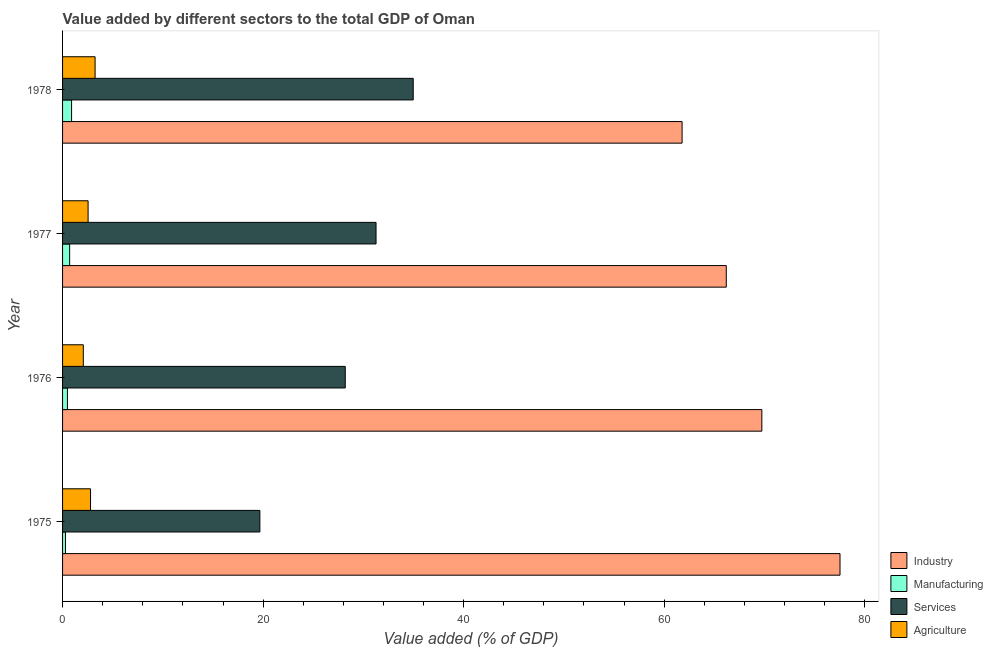How many different coloured bars are there?
Your answer should be very brief. 4. How many groups of bars are there?
Your answer should be compact. 4. Are the number of bars per tick equal to the number of legend labels?
Keep it short and to the point. Yes. Are the number of bars on each tick of the Y-axis equal?
Keep it short and to the point. Yes. How many bars are there on the 4th tick from the bottom?
Provide a succinct answer. 4. What is the label of the 1st group of bars from the top?
Your answer should be compact. 1978. What is the value added by manufacturing sector in 1976?
Offer a terse response. 0.49. Across all years, what is the maximum value added by industrial sector?
Your response must be concise. 77.53. Across all years, what is the minimum value added by services sector?
Your answer should be very brief. 19.68. In which year was the value added by manufacturing sector maximum?
Your response must be concise. 1978. In which year was the value added by manufacturing sector minimum?
Offer a terse response. 1975. What is the total value added by manufacturing sector in the graph?
Your response must be concise. 2.38. What is the difference between the value added by agricultural sector in 1975 and that in 1978?
Offer a terse response. -0.45. What is the difference between the value added by industrial sector in 1977 and the value added by services sector in 1975?
Make the answer very short. 46.51. What is the average value added by manufacturing sector per year?
Your answer should be compact. 0.59. In the year 1978, what is the difference between the value added by agricultural sector and value added by manufacturing sector?
Your response must be concise. 2.35. In how many years, is the value added by manufacturing sector greater than 16 %?
Provide a short and direct response. 0. What is the ratio of the value added by industrial sector in 1975 to that in 1976?
Provide a short and direct response. 1.11. Is the value added by services sector in 1975 less than that in 1976?
Offer a very short reply. Yes. What is the difference between the highest and the second highest value added by manufacturing sector?
Your answer should be compact. 0.19. What is the difference between the highest and the lowest value added by services sector?
Your answer should be compact. 15.29. In how many years, is the value added by services sector greater than the average value added by services sector taken over all years?
Offer a terse response. 2. Is it the case that in every year, the sum of the value added by services sector and value added by manufacturing sector is greater than the sum of value added by industrial sector and value added by agricultural sector?
Make the answer very short. Yes. What does the 4th bar from the top in 1978 represents?
Ensure brevity in your answer.  Industry. What does the 1st bar from the bottom in 1976 represents?
Offer a very short reply. Industry. Is it the case that in every year, the sum of the value added by industrial sector and value added by manufacturing sector is greater than the value added by services sector?
Make the answer very short. Yes. How many bars are there?
Provide a short and direct response. 16. Are all the bars in the graph horizontal?
Your answer should be compact. Yes. How many years are there in the graph?
Your answer should be very brief. 4. What is the difference between two consecutive major ticks on the X-axis?
Offer a very short reply. 20. Does the graph contain any zero values?
Your answer should be very brief. No. Does the graph contain grids?
Your answer should be compact. No. Where does the legend appear in the graph?
Ensure brevity in your answer.  Bottom right. How many legend labels are there?
Your answer should be very brief. 4. What is the title of the graph?
Provide a short and direct response. Value added by different sectors to the total GDP of Oman. What is the label or title of the X-axis?
Your answer should be very brief. Value added (% of GDP). What is the Value added (% of GDP) in Industry in 1975?
Offer a very short reply. 77.53. What is the Value added (% of GDP) of Manufacturing in 1975?
Your answer should be compact. 0.29. What is the Value added (% of GDP) of Services in 1975?
Keep it short and to the point. 19.68. What is the Value added (% of GDP) of Agriculture in 1975?
Offer a very short reply. 2.79. What is the Value added (% of GDP) of Industry in 1976?
Keep it short and to the point. 69.74. What is the Value added (% of GDP) in Manufacturing in 1976?
Your answer should be compact. 0.49. What is the Value added (% of GDP) of Services in 1976?
Provide a short and direct response. 28.19. What is the Value added (% of GDP) of Agriculture in 1976?
Provide a succinct answer. 2.07. What is the Value added (% of GDP) in Industry in 1977?
Provide a short and direct response. 66.19. What is the Value added (% of GDP) in Manufacturing in 1977?
Provide a short and direct response. 0.71. What is the Value added (% of GDP) in Services in 1977?
Make the answer very short. 31.26. What is the Value added (% of GDP) in Agriculture in 1977?
Give a very brief answer. 2.55. What is the Value added (% of GDP) of Industry in 1978?
Your answer should be very brief. 61.79. What is the Value added (% of GDP) in Manufacturing in 1978?
Your answer should be compact. 0.9. What is the Value added (% of GDP) of Services in 1978?
Keep it short and to the point. 34.97. What is the Value added (% of GDP) in Agriculture in 1978?
Make the answer very short. 3.24. Across all years, what is the maximum Value added (% of GDP) of Industry?
Keep it short and to the point. 77.53. Across all years, what is the maximum Value added (% of GDP) in Manufacturing?
Your answer should be compact. 0.9. Across all years, what is the maximum Value added (% of GDP) of Services?
Make the answer very short. 34.97. Across all years, what is the maximum Value added (% of GDP) of Agriculture?
Keep it short and to the point. 3.24. Across all years, what is the minimum Value added (% of GDP) in Industry?
Offer a terse response. 61.79. Across all years, what is the minimum Value added (% of GDP) in Manufacturing?
Make the answer very short. 0.29. Across all years, what is the minimum Value added (% of GDP) of Services?
Give a very brief answer. 19.68. Across all years, what is the minimum Value added (% of GDP) of Agriculture?
Provide a short and direct response. 2.07. What is the total Value added (% of GDP) of Industry in the graph?
Offer a very short reply. 275.25. What is the total Value added (% of GDP) in Manufacturing in the graph?
Give a very brief answer. 2.38. What is the total Value added (% of GDP) of Services in the graph?
Provide a succinct answer. 114.1. What is the total Value added (% of GDP) in Agriculture in the graph?
Your answer should be very brief. 10.65. What is the difference between the Value added (% of GDP) in Industry in 1975 and that in 1976?
Make the answer very short. 7.8. What is the difference between the Value added (% of GDP) of Manufacturing in 1975 and that in 1976?
Make the answer very short. -0.2. What is the difference between the Value added (% of GDP) of Services in 1975 and that in 1976?
Provide a succinct answer. -8.52. What is the difference between the Value added (% of GDP) of Agriculture in 1975 and that in 1976?
Your answer should be very brief. 0.72. What is the difference between the Value added (% of GDP) of Industry in 1975 and that in 1977?
Give a very brief answer. 11.34. What is the difference between the Value added (% of GDP) of Manufacturing in 1975 and that in 1977?
Offer a terse response. -0.42. What is the difference between the Value added (% of GDP) in Services in 1975 and that in 1977?
Offer a very short reply. -11.59. What is the difference between the Value added (% of GDP) of Agriculture in 1975 and that in 1977?
Give a very brief answer. 0.24. What is the difference between the Value added (% of GDP) in Industry in 1975 and that in 1978?
Keep it short and to the point. 15.75. What is the difference between the Value added (% of GDP) of Manufacturing in 1975 and that in 1978?
Offer a terse response. -0.61. What is the difference between the Value added (% of GDP) of Services in 1975 and that in 1978?
Keep it short and to the point. -15.29. What is the difference between the Value added (% of GDP) in Agriculture in 1975 and that in 1978?
Provide a succinct answer. -0.45. What is the difference between the Value added (% of GDP) in Industry in 1976 and that in 1977?
Offer a terse response. 3.55. What is the difference between the Value added (% of GDP) of Manufacturing in 1976 and that in 1977?
Your response must be concise. -0.22. What is the difference between the Value added (% of GDP) of Services in 1976 and that in 1977?
Provide a short and direct response. -3.07. What is the difference between the Value added (% of GDP) of Agriculture in 1976 and that in 1977?
Give a very brief answer. -0.48. What is the difference between the Value added (% of GDP) in Industry in 1976 and that in 1978?
Make the answer very short. 7.95. What is the difference between the Value added (% of GDP) of Manufacturing in 1976 and that in 1978?
Your answer should be compact. -0.41. What is the difference between the Value added (% of GDP) in Services in 1976 and that in 1978?
Make the answer very short. -6.78. What is the difference between the Value added (% of GDP) in Agriculture in 1976 and that in 1978?
Offer a very short reply. -1.17. What is the difference between the Value added (% of GDP) in Industry in 1977 and that in 1978?
Your response must be concise. 4.41. What is the difference between the Value added (% of GDP) of Manufacturing in 1977 and that in 1978?
Give a very brief answer. -0.19. What is the difference between the Value added (% of GDP) in Services in 1977 and that in 1978?
Provide a short and direct response. -3.71. What is the difference between the Value added (% of GDP) of Agriculture in 1977 and that in 1978?
Your answer should be very brief. -0.7. What is the difference between the Value added (% of GDP) of Industry in 1975 and the Value added (% of GDP) of Manufacturing in 1976?
Make the answer very short. 77.05. What is the difference between the Value added (% of GDP) in Industry in 1975 and the Value added (% of GDP) in Services in 1976?
Make the answer very short. 49.34. What is the difference between the Value added (% of GDP) of Industry in 1975 and the Value added (% of GDP) of Agriculture in 1976?
Provide a succinct answer. 75.46. What is the difference between the Value added (% of GDP) of Manufacturing in 1975 and the Value added (% of GDP) of Services in 1976?
Your response must be concise. -27.9. What is the difference between the Value added (% of GDP) of Manufacturing in 1975 and the Value added (% of GDP) of Agriculture in 1976?
Offer a terse response. -1.78. What is the difference between the Value added (% of GDP) in Services in 1975 and the Value added (% of GDP) in Agriculture in 1976?
Your response must be concise. 17.61. What is the difference between the Value added (% of GDP) of Industry in 1975 and the Value added (% of GDP) of Manufacturing in 1977?
Keep it short and to the point. 76.83. What is the difference between the Value added (% of GDP) in Industry in 1975 and the Value added (% of GDP) in Services in 1977?
Make the answer very short. 46.27. What is the difference between the Value added (% of GDP) in Industry in 1975 and the Value added (% of GDP) in Agriculture in 1977?
Provide a succinct answer. 74.99. What is the difference between the Value added (% of GDP) in Manufacturing in 1975 and the Value added (% of GDP) in Services in 1977?
Your answer should be very brief. -30.97. What is the difference between the Value added (% of GDP) in Manufacturing in 1975 and the Value added (% of GDP) in Agriculture in 1977?
Keep it short and to the point. -2.26. What is the difference between the Value added (% of GDP) of Services in 1975 and the Value added (% of GDP) of Agriculture in 1977?
Provide a short and direct response. 17.13. What is the difference between the Value added (% of GDP) in Industry in 1975 and the Value added (% of GDP) in Manufacturing in 1978?
Offer a very short reply. 76.64. What is the difference between the Value added (% of GDP) of Industry in 1975 and the Value added (% of GDP) of Services in 1978?
Give a very brief answer. 42.56. What is the difference between the Value added (% of GDP) in Industry in 1975 and the Value added (% of GDP) in Agriculture in 1978?
Your response must be concise. 74.29. What is the difference between the Value added (% of GDP) in Manufacturing in 1975 and the Value added (% of GDP) in Services in 1978?
Your response must be concise. -34.68. What is the difference between the Value added (% of GDP) in Manufacturing in 1975 and the Value added (% of GDP) in Agriculture in 1978?
Your answer should be compact. -2.95. What is the difference between the Value added (% of GDP) of Services in 1975 and the Value added (% of GDP) of Agriculture in 1978?
Ensure brevity in your answer.  16.43. What is the difference between the Value added (% of GDP) in Industry in 1976 and the Value added (% of GDP) in Manufacturing in 1977?
Make the answer very short. 69.03. What is the difference between the Value added (% of GDP) of Industry in 1976 and the Value added (% of GDP) of Services in 1977?
Provide a short and direct response. 38.48. What is the difference between the Value added (% of GDP) in Industry in 1976 and the Value added (% of GDP) in Agriculture in 1977?
Your answer should be compact. 67.19. What is the difference between the Value added (% of GDP) of Manufacturing in 1976 and the Value added (% of GDP) of Services in 1977?
Give a very brief answer. -30.78. What is the difference between the Value added (% of GDP) in Manufacturing in 1976 and the Value added (% of GDP) in Agriculture in 1977?
Your answer should be very brief. -2.06. What is the difference between the Value added (% of GDP) in Services in 1976 and the Value added (% of GDP) in Agriculture in 1977?
Make the answer very short. 25.65. What is the difference between the Value added (% of GDP) of Industry in 1976 and the Value added (% of GDP) of Manufacturing in 1978?
Make the answer very short. 68.84. What is the difference between the Value added (% of GDP) in Industry in 1976 and the Value added (% of GDP) in Services in 1978?
Give a very brief answer. 34.77. What is the difference between the Value added (% of GDP) in Industry in 1976 and the Value added (% of GDP) in Agriculture in 1978?
Ensure brevity in your answer.  66.5. What is the difference between the Value added (% of GDP) of Manufacturing in 1976 and the Value added (% of GDP) of Services in 1978?
Offer a terse response. -34.48. What is the difference between the Value added (% of GDP) in Manufacturing in 1976 and the Value added (% of GDP) in Agriculture in 1978?
Give a very brief answer. -2.76. What is the difference between the Value added (% of GDP) of Services in 1976 and the Value added (% of GDP) of Agriculture in 1978?
Give a very brief answer. 24.95. What is the difference between the Value added (% of GDP) in Industry in 1977 and the Value added (% of GDP) in Manufacturing in 1978?
Keep it short and to the point. 65.29. What is the difference between the Value added (% of GDP) in Industry in 1977 and the Value added (% of GDP) in Services in 1978?
Offer a very short reply. 31.22. What is the difference between the Value added (% of GDP) in Industry in 1977 and the Value added (% of GDP) in Agriculture in 1978?
Offer a terse response. 62.95. What is the difference between the Value added (% of GDP) of Manufacturing in 1977 and the Value added (% of GDP) of Services in 1978?
Your answer should be very brief. -34.26. What is the difference between the Value added (% of GDP) of Manufacturing in 1977 and the Value added (% of GDP) of Agriculture in 1978?
Give a very brief answer. -2.54. What is the difference between the Value added (% of GDP) of Services in 1977 and the Value added (% of GDP) of Agriculture in 1978?
Provide a short and direct response. 28.02. What is the average Value added (% of GDP) in Industry per year?
Your answer should be compact. 68.81. What is the average Value added (% of GDP) of Manufacturing per year?
Provide a short and direct response. 0.6. What is the average Value added (% of GDP) of Services per year?
Ensure brevity in your answer.  28.53. What is the average Value added (% of GDP) in Agriculture per year?
Your response must be concise. 2.66. In the year 1975, what is the difference between the Value added (% of GDP) in Industry and Value added (% of GDP) in Manufacturing?
Offer a very short reply. 77.24. In the year 1975, what is the difference between the Value added (% of GDP) in Industry and Value added (% of GDP) in Services?
Your response must be concise. 57.86. In the year 1975, what is the difference between the Value added (% of GDP) in Industry and Value added (% of GDP) in Agriculture?
Your response must be concise. 74.74. In the year 1975, what is the difference between the Value added (% of GDP) in Manufacturing and Value added (% of GDP) in Services?
Provide a short and direct response. -19.39. In the year 1975, what is the difference between the Value added (% of GDP) of Manufacturing and Value added (% of GDP) of Agriculture?
Your answer should be compact. -2.5. In the year 1975, what is the difference between the Value added (% of GDP) of Services and Value added (% of GDP) of Agriculture?
Offer a very short reply. 16.89. In the year 1976, what is the difference between the Value added (% of GDP) in Industry and Value added (% of GDP) in Manufacturing?
Your answer should be compact. 69.25. In the year 1976, what is the difference between the Value added (% of GDP) in Industry and Value added (% of GDP) in Services?
Your response must be concise. 41.55. In the year 1976, what is the difference between the Value added (% of GDP) of Industry and Value added (% of GDP) of Agriculture?
Provide a succinct answer. 67.67. In the year 1976, what is the difference between the Value added (% of GDP) in Manufacturing and Value added (% of GDP) in Services?
Offer a terse response. -27.71. In the year 1976, what is the difference between the Value added (% of GDP) in Manufacturing and Value added (% of GDP) in Agriculture?
Make the answer very short. -1.58. In the year 1976, what is the difference between the Value added (% of GDP) in Services and Value added (% of GDP) in Agriculture?
Offer a terse response. 26.12. In the year 1977, what is the difference between the Value added (% of GDP) in Industry and Value added (% of GDP) in Manufacturing?
Your response must be concise. 65.48. In the year 1977, what is the difference between the Value added (% of GDP) in Industry and Value added (% of GDP) in Services?
Ensure brevity in your answer.  34.93. In the year 1977, what is the difference between the Value added (% of GDP) in Industry and Value added (% of GDP) in Agriculture?
Make the answer very short. 63.65. In the year 1977, what is the difference between the Value added (% of GDP) of Manufacturing and Value added (% of GDP) of Services?
Make the answer very short. -30.56. In the year 1977, what is the difference between the Value added (% of GDP) of Manufacturing and Value added (% of GDP) of Agriculture?
Make the answer very short. -1.84. In the year 1977, what is the difference between the Value added (% of GDP) in Services and Value added (% of GDP) in Agriculture?
Make the answer very short. 28.72. In the year 1978, what is the difference between the Value added (% of GDP) of Industry and Value added (% of GDP) of Manufacturing?
Your response must be concise. 60.89. In the year 1978, what is the difference between the Value added (% of GDP) of Industry and Value added (% of GDP) of Services?
Your answer should be very brief. 26.81. In the year 1978, what is the difference between the Value added (% of GDP) in Industry and Value added (% of GDP) in Agriculture?
Your answer should be compact. 58.54. In the year 1978, what is the difference between the Value added (% of GDP) of Manufacturing and Value added (% of GDP) of Services?
Provide a short and direct response. -34.07. In the year 1978, what is the difference between the Value added (% of GDP) of Manufacturing and Value added (% of GDP) of Agriculture?
Your response must be concise. -2.35. In the year 1978, what is the difference between the Value added (% of GDP) in Services and Value added (% of GDP) in Agriculture?
Keep it short and to the point. 31.73. What is the ratio of the Value added (% of GDP) of Industry in 1975 to that in 1976?
Your answer should be very brief. 1.11. What is the ratio of the Value added (% of GDP) of Manufacturing in 1975 to that in 1976?
Offer a terse response. 0.6. What is the ratio of the Value added (% of GDP) of Services in 1975 to that in 1976?
Your answer should be compact. 0.7. What is the ratio of the Value added (% of GDP) in Agriculture in 1975 to that in 1976?
Provide a succinct answer. 1.35. What is the ratio of the Value added (% of GDP) in Industry in 1975 to that in 1977?
Your response must be concise. 1.17. What is the ratio of the Value added (% of GDP) of Manufacturing in 1975 to that in 1977?
Your answer should be compact. 0.41. What is the ratio of the Value added (% of GDP) in Services in 1975 to that in 1977?
Ensure brevity in your answer.  0.63. What is the ratio of the Value added (% of GDP) in Agriculture in 1975 to that in 1977?
Provide a succinct answer. 1.1. What is the ratio of the Value added (% of GDP) of Industry in 1975 to that in 1978?
Your answer should be compact. 1.25. What is the ratio of the Value added (% of GDP) in Manufacturing in 1975 to that in 1978?
Provide a succinct answer. 0.32. What is the ratio of the Value added (% of GDP) in Services in 1975 to that in 1978?
Give a very brief answer. 0.56. What is the ratio of the Value added (% of GDP) of Agriculture in 1975 to that in 1978?
Offer a very short reply. 0.86. What is the ratio of the Value added (% of GDP) in Industry in 1976 to that in 1977?
Provide a short and direct response. 1.05. What is the ratio of the Value added (% of GDP) of Manufacturing in 1976 to that in 1977?
Provide a short and direct response. 0.69. What is the ratio of the Value added (% of GDP) of Services in 1976 to that in 1977?
Make the answer very short. 0.9. What is the ratio of the Value added (% of GDP) in Agriculture in 1976 to that in 1977?
Your answer should be compact. 0.81. What is the ratio of the Value added (% of GDP) in Industry in 1976 to that in 1978?
Give a very brief answer. 1.13. What is the ratio of the Value added (% of GDP) in Manufacturing in 1976 to that in 1978?
Provide a succinct answer. 0.54. What is the ratio of the Value added (% of GDP) in Services in 1976 to that in 1978?
Offer a very short reply. 0.81. What is the ratio of the Value added (% of GDP) in Agriculture in 1976 to that in 1978?
Your answer should be compact. 0.64. What is the ratio of the Value added (% of GDP) of Industry in 1977 to that in 1978?
Offer a terse response. 1.07. What is the ratio of the Value added (% of GDP) in Manufacturing in 1977 to that in 1978?
Provide a short and direct response. 0.79. What is the ratio of the Value added (% of GDP) in Services in 1977 to that in 1978?
Make the answer very short. 0.89. What is the ratio of the Value added (% of GDP) of Agriculture in 1977 to that in 1978?
Your response must be concise. 0.78. What is the difference between the highest and the second highest Value added (% of GDP) in Industry?
Keep it short and to the point. 7.8. What is the difference between the highest and the second highest Value added (% of GDP) in Manufacturing?
Your answer should be compact. 0.19. What is the difference between the highest and the second highest Value added (% of GDP) in Services?
Make the answer very short. 3.71. What is the difference between the highest and the second highest Value added (% of GDP) of Agriculture?
Make the answer very short. 0.45. What is the difference between the highest and the lowest Value added (% of GDP) of Industry?
Provide a succinct answer. 15.75. What is the difference between the highest and the lowest Value added (% of GDP) in Manufacturing?
Make the answer very short. 0.61. What is the difference between the highest and the lowest Value added (% of GDP) of Services?
Your answer should be very brief. 15.29. What is the difference between the highest and the lowest Value added (% of GDP) of Agriculture?
Your answer should be very brief. 1.17. 